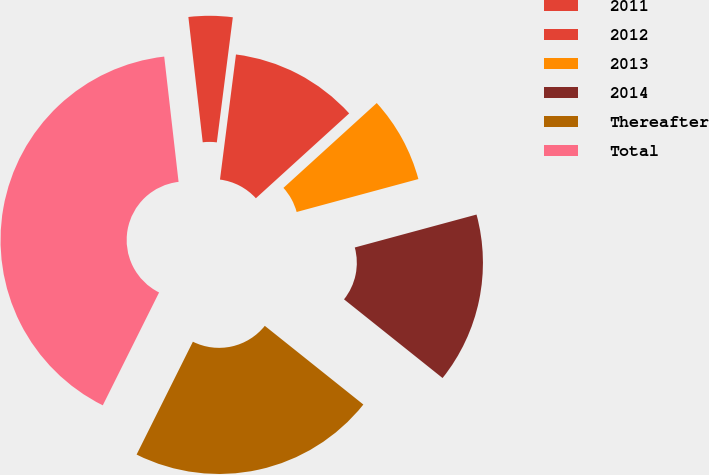Convert chart to OTSL. <chart><loc_0><loc_0><loc_500><loc_500><pie_chart><fcel>2011<fcel>2012<fcel>2013<fcel>2014<fcel>Thereafter<fcel>Total<nl><fcel>3.84%<fcel>11.23%<fcel>7.54%<fcel>14.93%<fcel>21.64%<fcel>40.82%<nl></chart> 